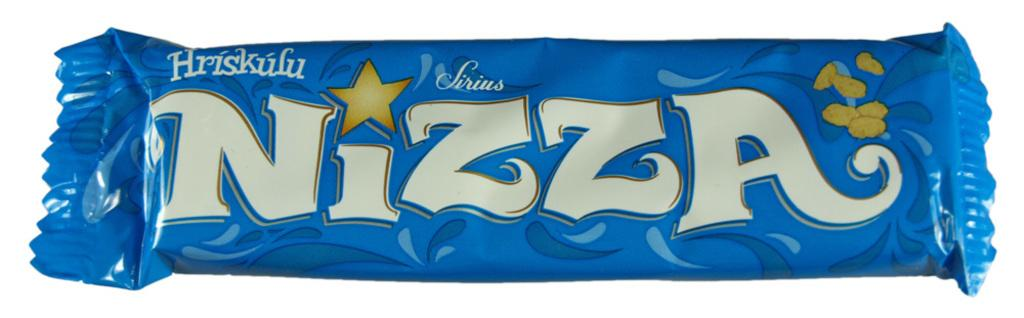What type of food item is present in the image? There is a chocolate bar in the image. What color is the background of the image? The background of the image is white. Where are the cherries stored in the image? There are no cherries present in the image. What type of drain is visible in the image? There is no drain present in the image. 